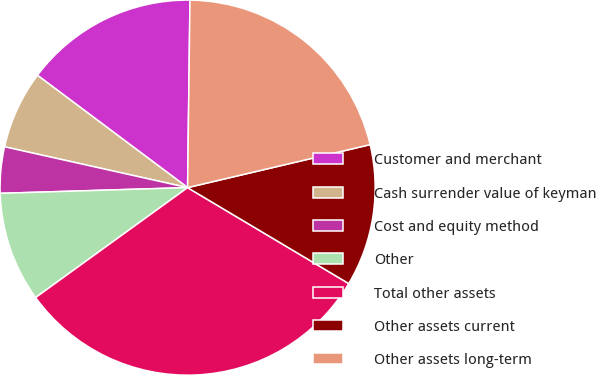Convert chart. <chart><loc_0><loc_0><loc_500><loc_500><pie_chart><fcel>Customer and merchant<fcel>Cash surrender value of keyman<fcel>Cost and equity method<fcel>Other<fcel>Total other assets<fcel>Other assets current<fcel>Other assets long-term<nl><fcel>14.98%<fcel>6.73%<fcel>3.98%<fcel>9.48%<fcel>31.49%<fcel>12.23%<fcel>21.12%<nl></chart> 